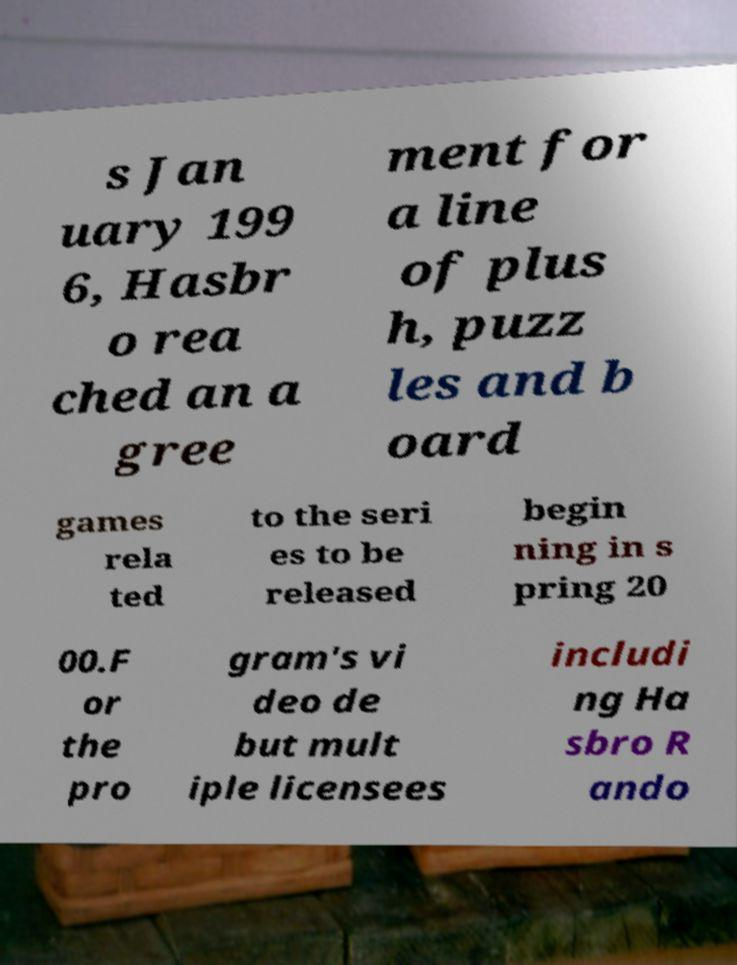There's text embedded in this image that I need extracted. Can you transcribe it verbatim? s Jan uary 199 6, Hasbr o rea ched an a gree ment for a line of plus h, puzz les and b oard games rela ted to the seri es to be released begin ning in s pring 20 00.F or the pro gram's vi deo de but mult iple licensees includi ng Ha sbro R ando 